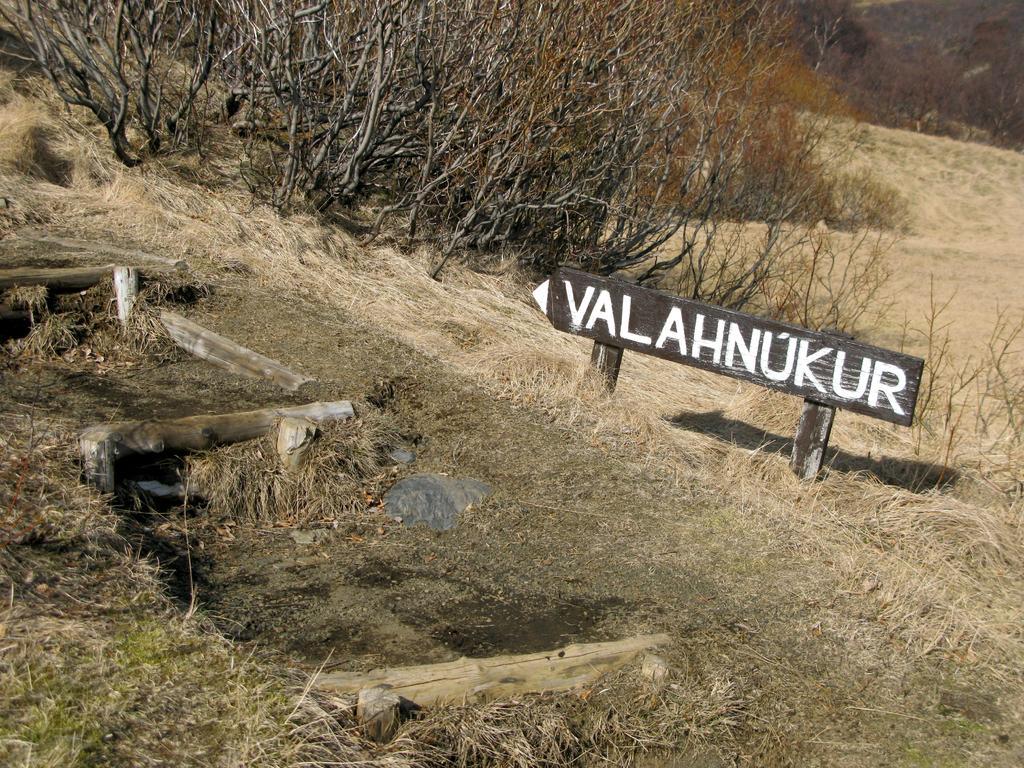Can you describe this image briefly? In this image, we can see a sign board and there are some dried trees and grass on the ground. 